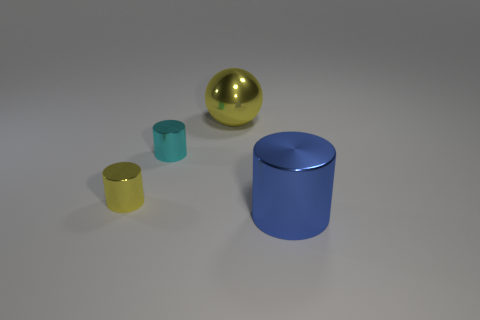Subtract all cyan balls. Subtract all brown blocks. How many balls are left? 1 Add 3 big yellow metal things. How many objects exist? 7 Subtract all cylinders. How many objects are left? 1 Subtract all big shiny cylinders. Subtract all small metal objects. How many objects are left? 1 Add 3 cyan cylinders. How many cyan cylinders are left? 4 Add 1 small cyan metal blocks. How many small cyan metal blocks exist? 1 Subtract 0 gray cylinders. How many objects are left? 4 